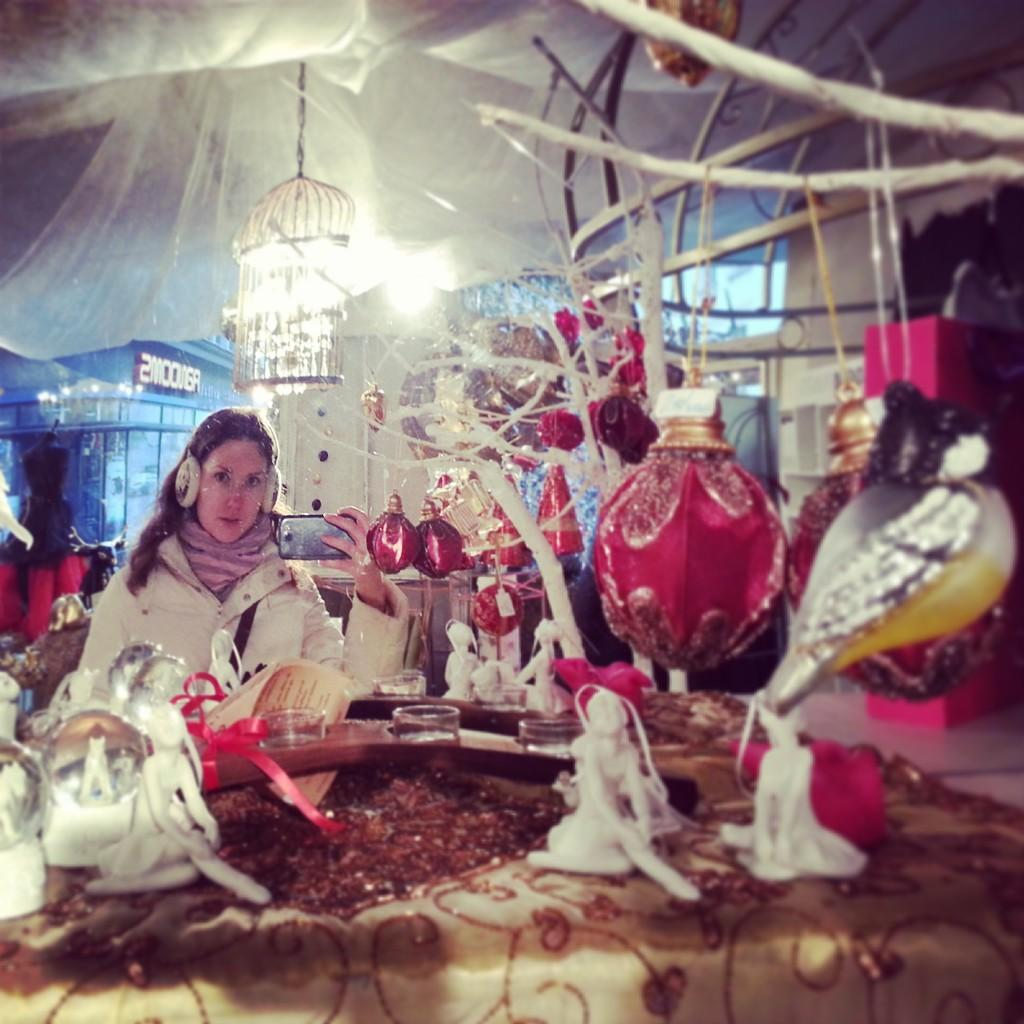What types of objects can be seen in the image? There are decorative things and toys in the image. Where is the woman located in the image? The woman is on the left side of the image. What is the woman holding in the image? The woman is holding a mobile. What can be seen behind the woman in the image? There are lights visible behind the woman. Can you see any airplanes flying over the grass in the image? There is no grass or airplane present in the image. How many rings is the woman wearing on her fingers in the image? There is no mention of rings or fingers in the image; the woman is holding a mobile. 